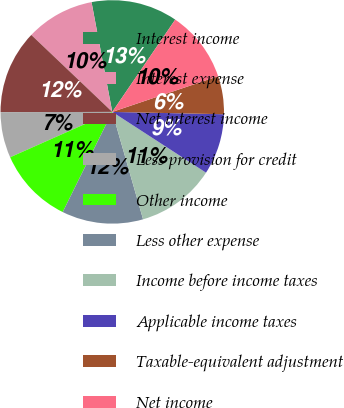Convert chart. <chart><loc_0><loc_0><loc_500><loc_500><pie_chart><fcel>Interest income<fcel>Interest expense<fcel>Net interest income<fcel>Less provision for credit<fcel>Other income<fcel>Less other expense<fcel>Income before income taxes<fcel>Applicable income taxes<fcel>Taxable-equivalent adjustment<fcel>Net income<nl><fcel>12.5%<fcel>9.93%<fcel>12.13%<fcel>6.62%<fcel>11.03%<fcel>11.76%<fcel>11.4%<fcel>8.82%<fcel>5.51%<fcel>10.29%<nl></chart> 